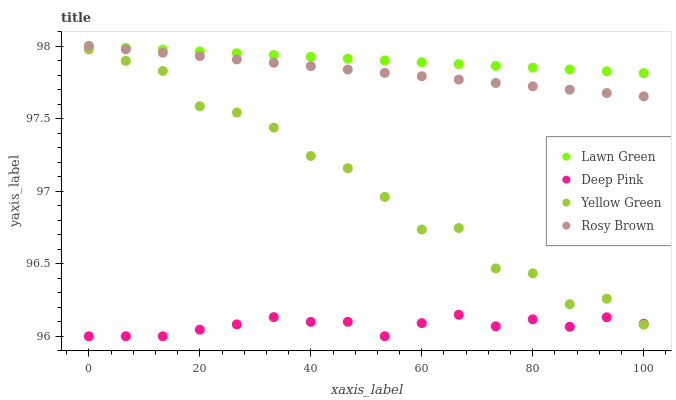Does Deep Pink have the minimum area under the curve?
Answer yes or no. Yes. Does Lawn Green have the maximum area under the curve?
Answer yes or no. Yes. Does Rosy Brown have the minimum area under the curve?
Answer yes or no. No. Does Rosy Brown have the maximum area under the curve?
Answer yes or no. No. Is Lawn Green the smoothest?
Answer yes or no. Yes. Is Yellow Green the roughest?
Answer yes or no. Yes. Is Rosy Brown the smoothest?
Answer yes or no. No. Is Rosy Brown the roughest?
Answer yes or no. No. Does Deep Pink have the lowest value?
Answer yes or no. Yes. Does Rosy Brown have the lowest value?
Answer yes or no. No. Does Rosy Brown have the highest value?
Answer yes or no. Yes. Does Deep Pink have the highest value?
Answer yes or no. No. Is Deep Pink less than Lawn Green?
Answer yes or no. Yes. Is Lawn Green greater than Deep Pink?
Answer yes or no. Yes. Does Lawn Green intersect Rosy Brown?
Answer yes or no. Yes. Is Lawn Green less than Rosy Brown?
Answer yes or no. No. Is Lawn Green greater than Rosy Brown?
Answer yes or no. No. Does Deep Pink intersect Lawn Green?
Answer yes or no. No. 